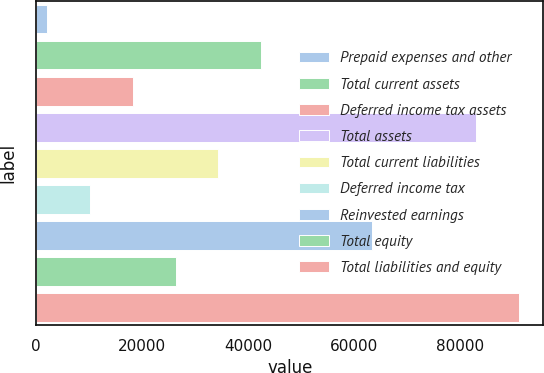Convert chart. <chart><loc_0><loc_0><loc_500><loc_500><bar_chart><fcel>Prepaid expenses and other<fcel>Total current assets<fcel>Deferred income tax assets<fcel>Total assets<fcel>Total current liabilities<fcel>Deferred income tax<fcel>Reinvested earnings<fcel>Total equity<fcel>Total liabilities and equity<nl><fcel>1970<fcel>42541<fcel>18198.4<fcel>83112<fcel>34426.8<fcel>10084.2<fcel>63480<fcel>26312.6<fcel>91226.2<nl></chart> 